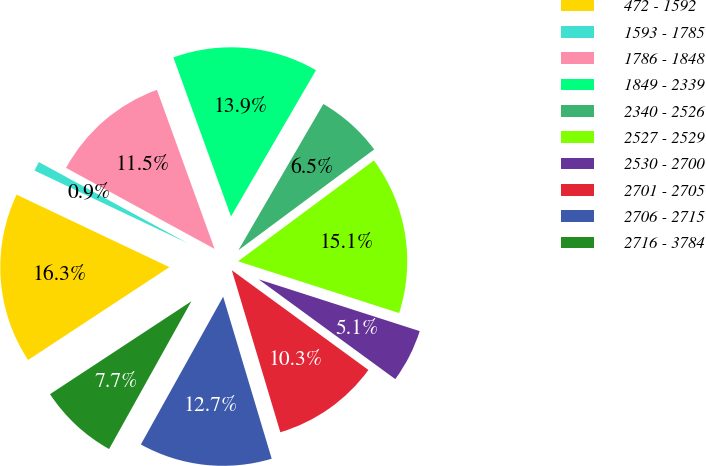Convert chart. <chart><loc_0><loc_0><loc_500><loc_500><pie_chart><fcel>472 - 1592<fcel>1593 - 1785<fcel>1786 - 1848<fcel>1849 - 2339<fcel>2340 - 2526<fcel>2527 - 2529<fcel>2530 - 2700<fcel>2701 - 2705<fcel>2706 - 2715<fcel>2716 - 3784<nl><fcel>16.3%<fcel>0.9%<fcel>11.52%<fcel>13.91%<fcel>6.46%<fcel>15.11%<fcel>5.09%<fcel>10.33%<fcel>12.72%<fcel>7.66%<nl></chart> 